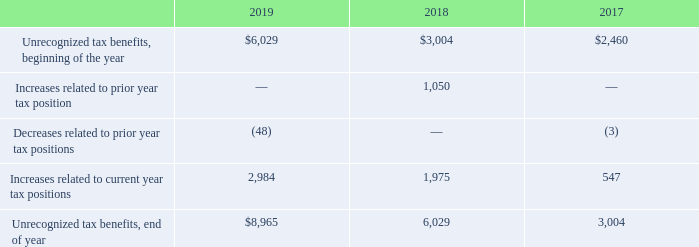In accordance with ASC 740-10, Income Taxes, the Company has adopted the accounting policy that interest and penalties recognized are classified as part of its income taxes
The following shows the changes in the gross amount of unrecognized tax benefits as of December 31, 2019 (in thousands):
The Company does not anticipate that its total unrecognized tax benefits will significantly change due to settlement of examination or the expiration of statute of limitations during the next 12 months.
The Company files U.S. and foreign income tax returns with varying statutes of limitations. Due to the Company’s net carry-over of unused operating losses and tax credits, all years from 2003 forward remain subject to future examination by tax authorities
What are the respective unrecognised tax benefits at the beginning of the year in 2017 and 2018?
Answer scale should be: thousand. $2,460, $3,004. What are the respective unrecognised tax benefits at the beginning of the year in 2018 and 2019?
Answer scale should be: thousand. $3,004, $6,029. What are the respective increases related to current year tax positions in 2017 and 2018?
Answer scale should be: thousand. 547, 1,975. What is the percentage change in the unrecognized tax benefits, beginning of the year between 2017 and 2018?
Answer scale should be: percent. (3,004 - 2,460)/2,460 
Answer: 22.11. What is the percentage change in the unrecognized tax benefits at the beginning of the year between 2018 and 2019?
Answer scale should be: percent. (6,029 - 3,004)/3,004 
Answer: 100.7. What is the average increases related to current year tax positions between 2017 to 2019?
Answer scale should be: thousand. (2,984 + 1,975 + 547)/3 
Answer: 1835.33. 